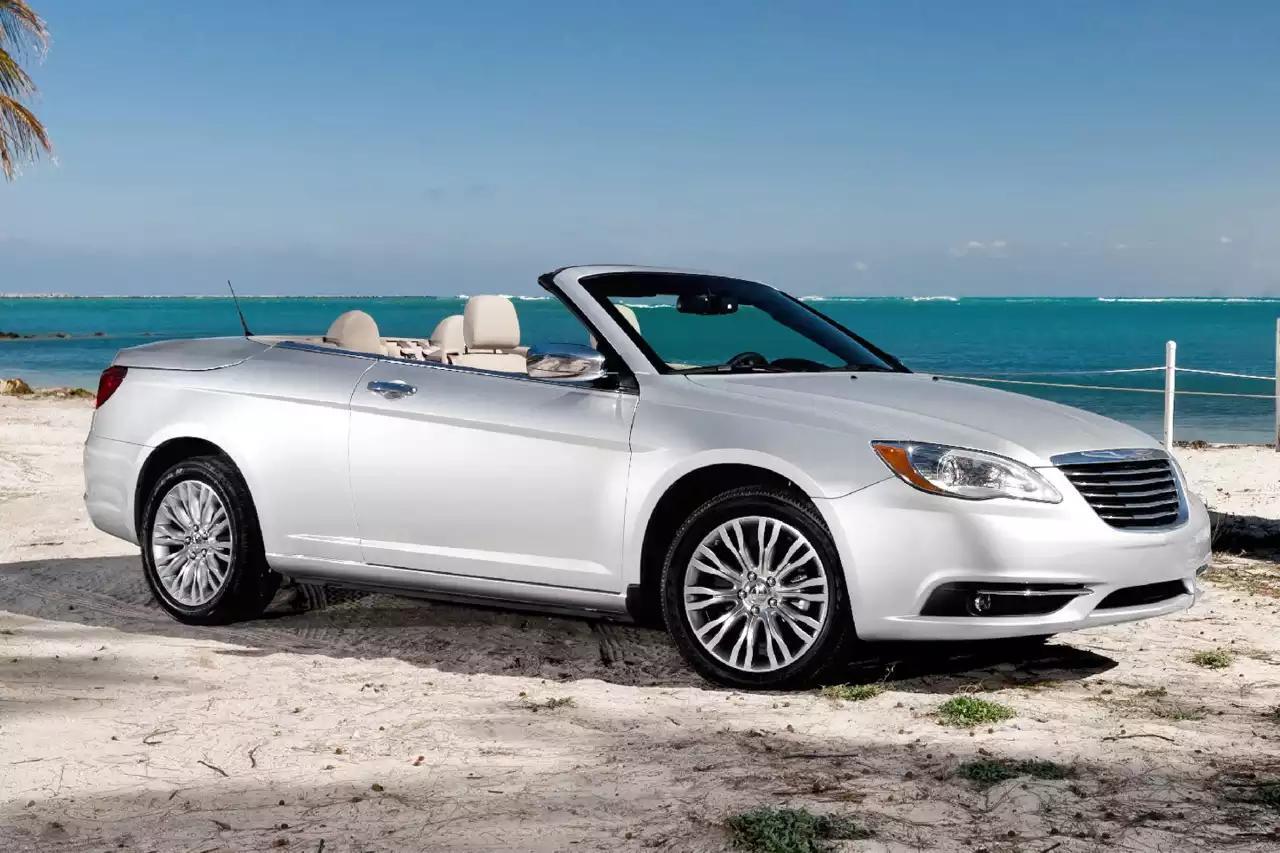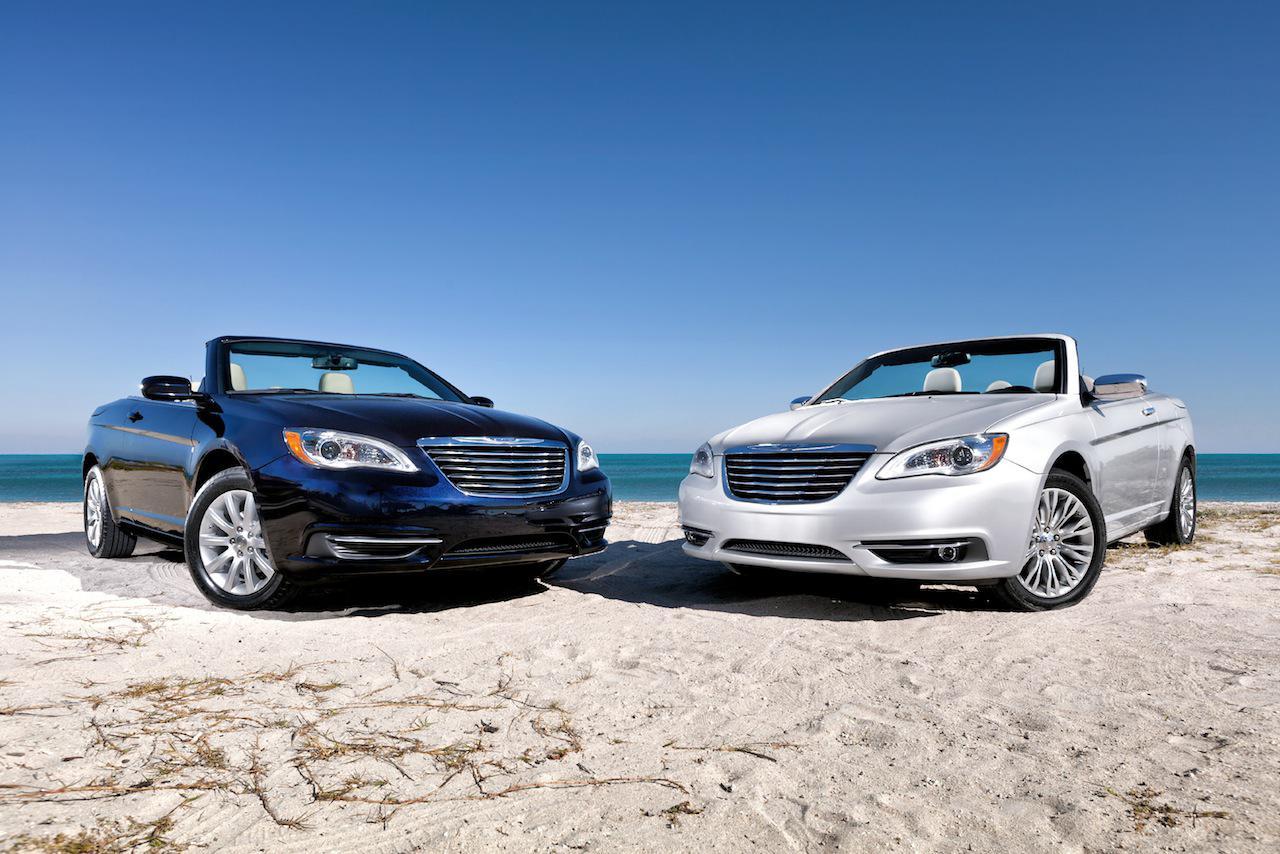The first image is the image on the left, the second image is the image on the right. Assess this claim about the two images: "In the left image, there is a single blue convertible with its top down". Correct or not? Answer yes or no. No. The first image is the image on the left, the second image is the image on the right. Examine the images to the left and right. Is the description "The left image contains only one car and it is blue." accurate? Answer yes or no. No. 